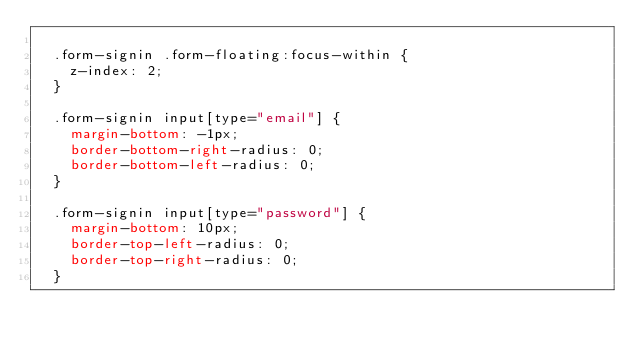Convert code to text. <code><loc_0><loc_0><loc_500><loc_500><_CSS_>  
  .form-signin .form-floating:focus-within {
    z-index: 2;
  }
  
  .form-signin input[type="email"] {
    margin-bottom: -1px;
    border-bottom-right-radius: 0;
    border-bottom-left-radius: 0;
  }
  
  .form-signin input[type="password"] {
    margin-bottom: 10px;
    border-top-left-radius: 0;
    border-top-right-radius: 0;
  }
  </code> 